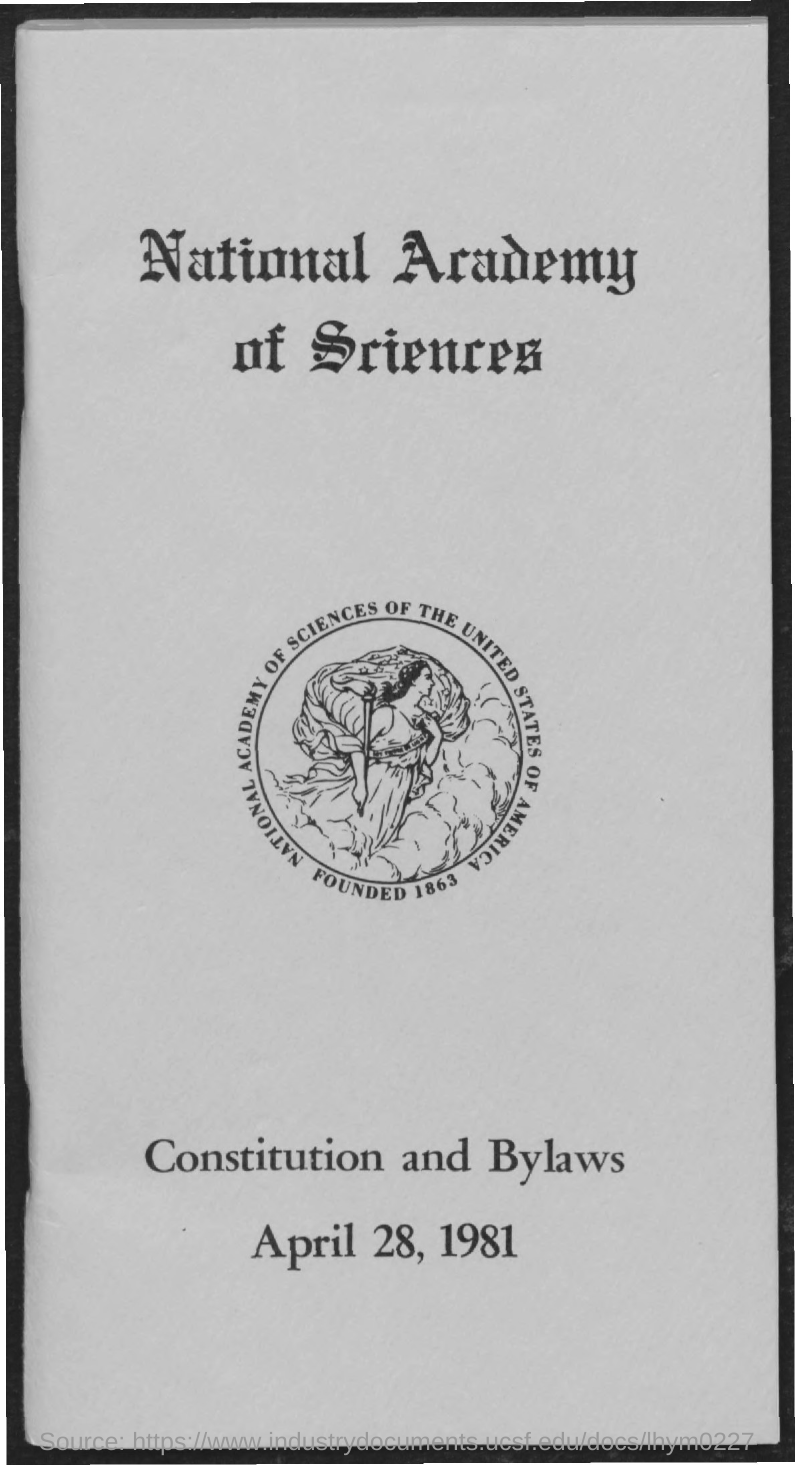Indicate a few pertinent items in this graphic. The date mentioned in the given page is April 28, 1981. 